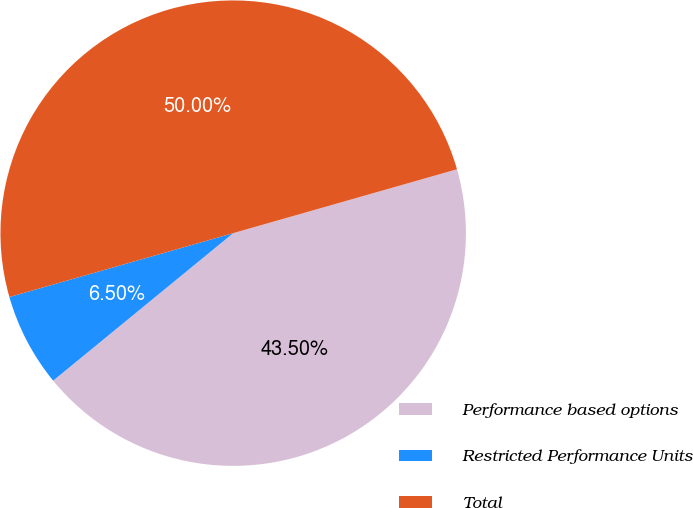Convert chart. <chart><loc_0><loc_0><loc_500><loc_500><pie_chart><fcel>Performance based options<fcel>Restricted Performance Units<fcel>Total<nl><fcel>43.5%<fcel>6.5%<fcel>50.0%<nl></chart> 